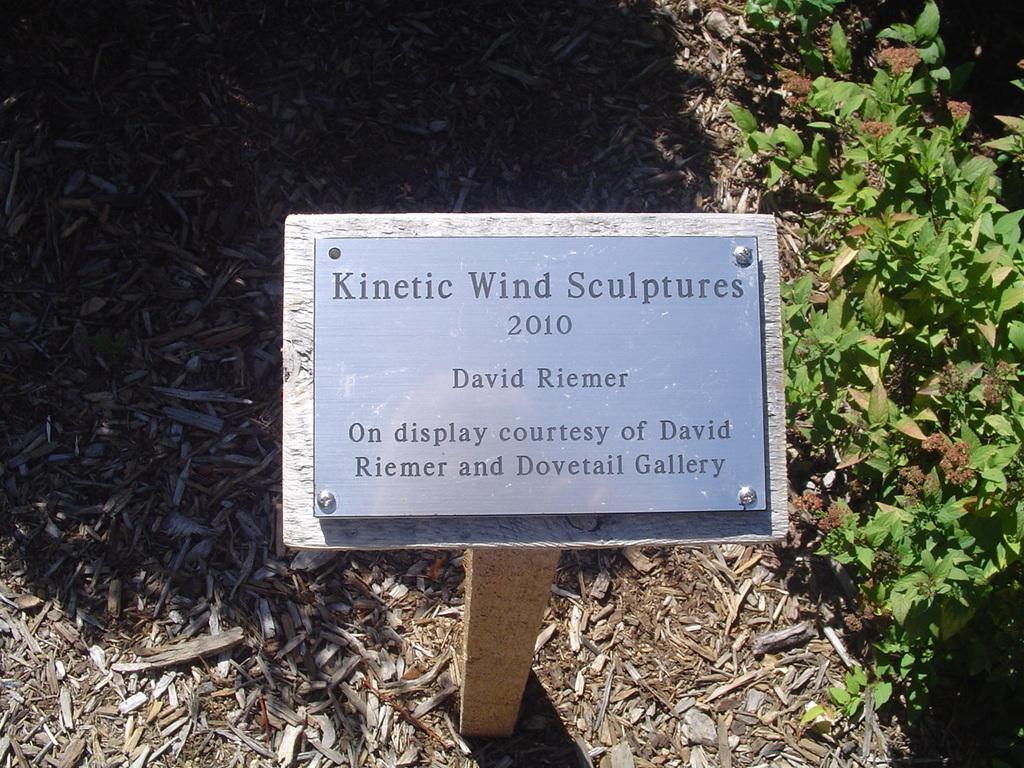Could you give a brief overview of what you see in this image? In this picture we can see sign board on the wooden stand. Beside that we can see plant. On the bottom we can see small wooden sticks. 